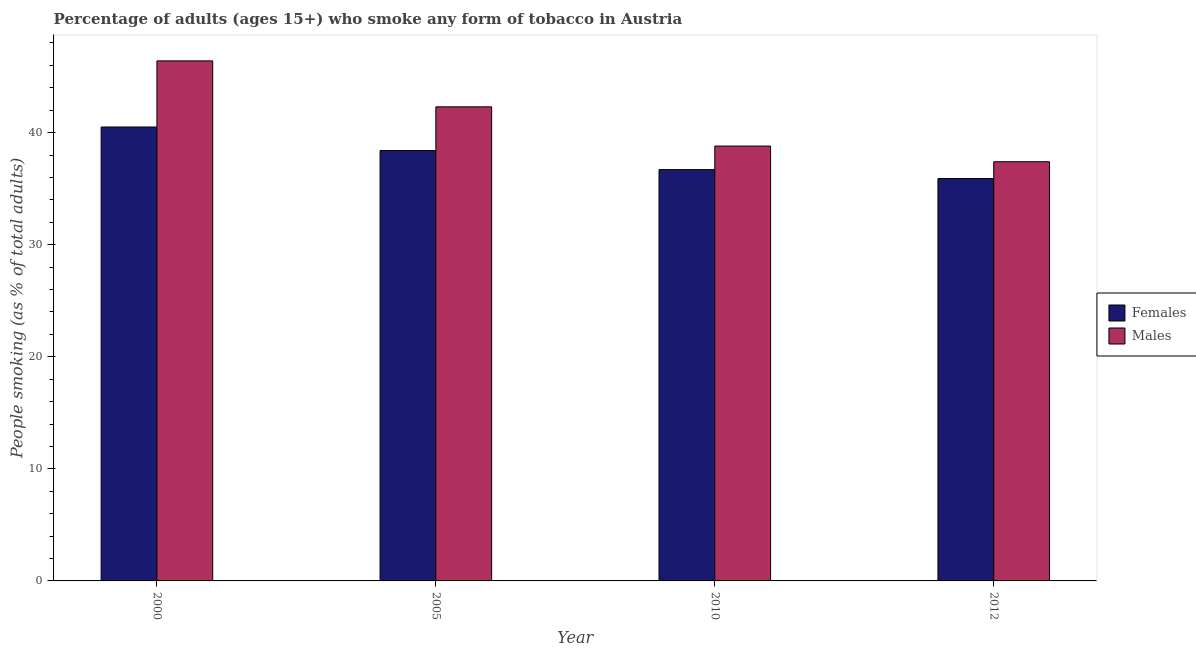How many different coloured bars are there?
Your answer should be very brief. 2. How many bars are there on the 3rd tick from the left?
Offer a terse response. 2. In how many cases, is the number of bars for a given year not equal to the number of legend labels?
Offer a terse response. 0. What is the percentage of males who smoke in 2012?
Provide a short and direct response. 37.4. Across all years, what is the maximum percentage of males who smoke?
Provide a short and direct response. 46.4. Across all years, what is the minimum percentage of males who smoke?
Offer a terse response. 37.4. In which year was the percentage of males who smoke minimum?
Your answer should be very brief. 2012. What is the total percentage of males who smoke in the graph?
Provide a succinct answer. 164.9. What is the difference between the percentage of males who smoke in 2010 and that in 2012?
Ensure brevity in your answer.  1.4. What is the difference between the percentage of males who smoke in 2005 and the percentage of females who smoke in 2010?
Provide a short and direct response. 3.5. What is the average percentage of females who smoke per year?
Provide a short and direct response. 37.88. In the year 2005, what is the difference between the percentage of males who smoke and percentage of females who smoke?
Provide a succinct answer. 0. In how many years, is the percentage of males who smoke greater than 28 %?
Provide a succinct answer. 4. What is the ratio of the percentage of males who smoke in 2000 to that in 2010?
Ensure brevity in your answer.  1.2. Is the percentage of males who smoke in 2005 less than that in 2010?
Keep it short and to the point. No. What is the difference between the highest and the second highest percentage of females who smoke?
Your answer should be very brief. 2.1. What is the difference between the highest and the lowest percentage of males who smoke?
Make the answer very short. 9. In how many years, is the percentage of males who smoke greater than the average percentage of males who smoke taken over all years?
Offer a terse response. 2. What does the 1st bar from the left in 2000 represents?
Your answer should be compact. Females. What does the 2nd bar from the right in 2000 represents?
Offer a very short reply. Females. Are all the bars in the graph horizontal?
Your answer should be very brief. No. What is the difference between two consecutive major ticks on the Y-axis?
Your answer should be very brief. 10. Are the values on the major ticks of Y-axis written in scientific E-notation?
Ensure brevity in your answer.  No. How many legend labels are there?
Offer a very short reply. 2. How are the legend labels stacked?
Your response must be concise. Vertical. What is the title of the graph?
Provide a short and direct response. Percentage of adults (ages 15+) who smoke any form of tobacco in Austria. What is the label or title of the X-axis?
Make the answer very short. Year. What is the label or title of the Y-axis?
Make the answer very short. People smoking (as % of total adults). What is the People smoking (as % of total adults) of Females in 2000?
Your answer should be compact. 40.5. What is the People smoking (as % of total adults) of Males in 2000?
Offer a terse response. 46.4. What is the People smoking (as % of total adults) in Females in 2005?
Make the answer very short. 38.4. What is the People smoking (as % of total adults) of Males in 2005?
Make the answer very short. 42.3. What is the People smoking (as % of total adults) in Females in 2010?
Keep it short and to the point. 36.7. What is the People smoking (as % of total adults) in Males in 2010?
Your answer should be very brief. 38.8. What is the People smoking (as % of total adults) of Females in 2012?
Provide a short and direct response. 35.9. What is the People smoking (as % of total adults) in Males in 2012?
Provide a short and direct response. 37.4. Across all years, what is the maximum People smoking (as % of total adults) of Females?
Give a very brief answer. 40.5. Across all years, what is the maximum People smoking (as % of total adults) in Males?
Your response must be concise. 46.4. Across all years, what is the minimum People smoking (as % of total adults) of Females?
Provide a succinct answer. 35.9. Across all years, what is the minimum People smoking (as % of total adults) of Males?
Make the answer very short. 37.4. What is the total People smoking (as % of total adults) in Females in the graph?
Provide a short and direct response. 151.5. What is the total People smoking (as % of total adults) of Males in the graph?
Ensure brevity in your answer.  164.9. What is the difference between the People smoking (as % of total adults) of Females in 2000 and that in 2010?
Ensure brevity in your answer.  3.8. What is the difference between the People smoking (as % of total adults) in Males in 2000 and that in 2010?
Ensure brevity in your answer.  7.6. What is the difference between the People smoking (as % of total adults) of Females in 2000 and that in 2012?
Provide a short and direct response. 4.6. What is the difference between the People smoking (as % of total adults) in Males in 2000 and that in 2012?
Make the answer very short. 9. What is the difference between the People smoking (as % of total adults) in Females in 2005 and that in 2010?
Keep it short and to the point. 1.7. What is the difference between the People smoking (as % of total adults) of Females in 2005 and that in 2012?
Offer a terse response. 2.5. What is the difference between the People smoking (as % of total adults) of Females in 2000 and the People smoking (as % of total adults) of Males in 2005?
Ensure brevity in your answer.  -1.8. What is the difference between the People smoking (as % of total adults) of Females in 2005 and the People smoking (as % of total adults) of Males in 2010?
Offer a very short reply. -0.4. What is the difference between the People smoking (as % of total adults) of Females in 2010 and the People smoking (as % of total adults) of Males in 2012?
Give a very brief answer. -0.7. What is the average People smoking (as % of total adults) in Females per year?
Your answer should be compact. 37.88. What is the average People smoking (as % of total adults) of Males per year?
Give a very brief answer. 41.23. In the year 2000, what is the difference between the People smoking (as % of total adults) in Females and People smoking (as % of total adults) in Males?
Ensure brevity in your answer.  -5.9. In the year 2010, what is the difference between the People smoking (as % of total adults) of Females and People smoking (as % of total adults) of Males?
Provide a short and direct response. -2.1. What is the ratio of the People smoking (as % of total adults) in Females in 2000 to that in 2005?
Your response must be concise. 1.05. What is the ratio of the People smoking (as % of total adults) in Males in 2000 to that in 2005?
Offer a very short reply. 1.1. What is the ratio of the People smoking (as % of total adults) of Females in 2000 to that in 2010?
Keep it short and to the point. 1.1. What is the ratio of the People smoking (as % of total adults) in Males in 2000 to that in 2010?
Ensure brevity in your answer.  1.2. What is the ratio of the People smoking (as % of total adults) of Females in 2000 to that in 2012?
Ensure brevity in your answer.  1.13. What is the ratio of the People smoking (as % of total adults) of Males in 2000 to that in 2012?
Give a very brief answer. 1.24. What is the ratio of the People smoking (as % of total adults) of Females in 2005 to that in 2010?
Keep it short and to the point. 1.05. What is the ratio of the People smoking (as % of total adults) of Males in 2005 to that in 2010?
Your response must be concise. 1.09. What is the ratio of the People smoking (as % of total adults) of Females in 2005 to that in 2012?
Provide a succinct answer. 1.07. What is the ratio of the People smoking (as % of total adults) in Males in 2005 to that in 2012?
Your answer should be very brief. 1.13. What is the ratio of the People smoking (as % of total adults) of Females in 2010 to that in 2012?
Your answer should be very brief. 1.02. What is the ratio of the People smoking (as % of total adults) of Males in 2010 to that in 2012?
Ensure brevity in your answer.  1.04. What is the difference between the highest and the second highest People smoking (as % of total adults) of Males?
Offer a very short reply. 4.1. What is the difference between the highest and the lowest People smoking (as % of total adults) of Females?
Provide a succinct answer. 4.6. 